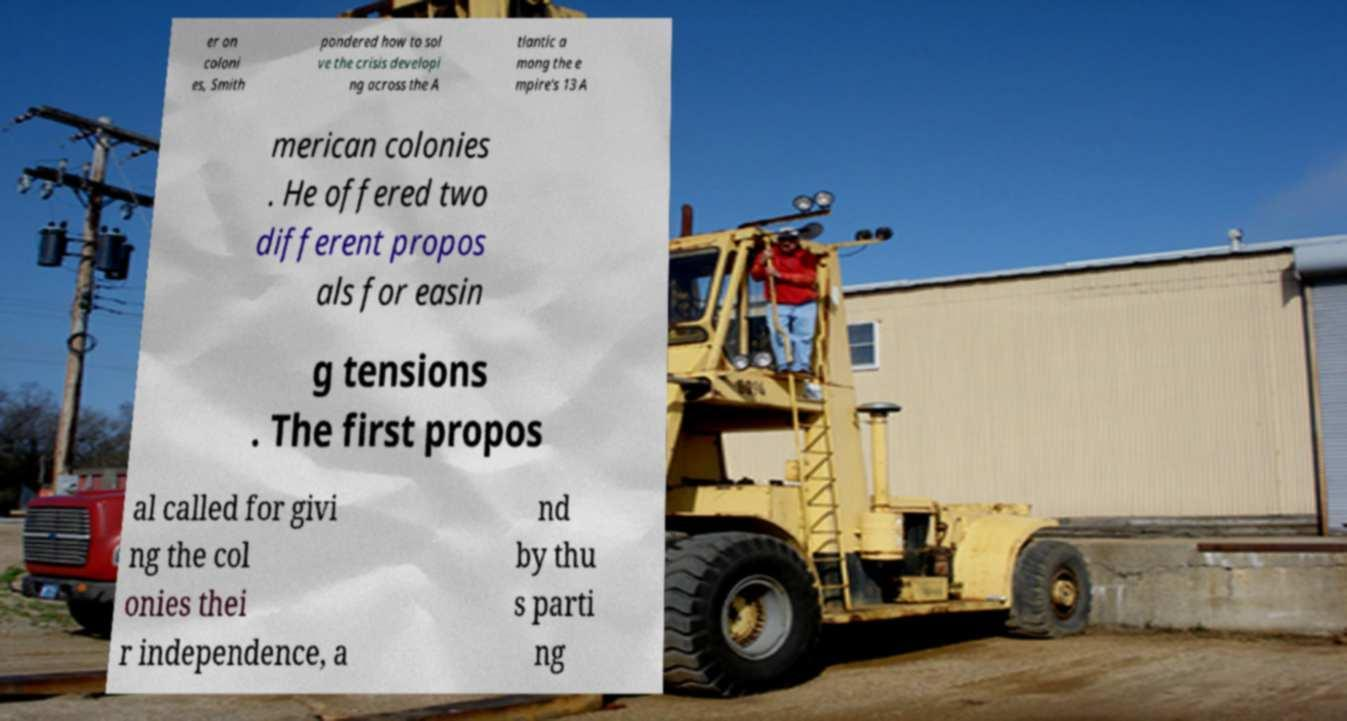Can you read and provide the text displayed in the image?This photo seems to have some interesting text. Can you extract and type it out for me? er on coloni es, Smith pondered how to sol ve the crisis developi ng across the A tlantic a mong the e mpire's 13 A merican colonies . He offered two different propos als for easin g tensions . The first propos al called for givi ng the col onies thei r independence, a nd by thu s parti ng 